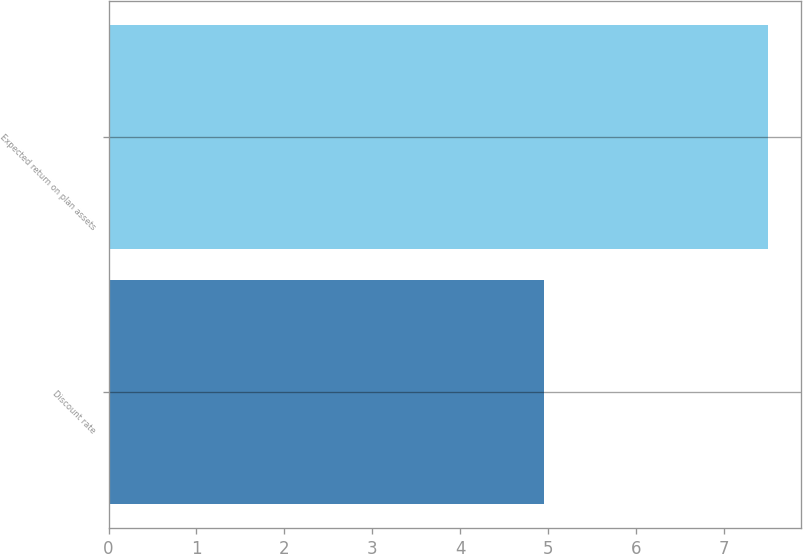<chart> <loc_0><loc_0><loc_500><loc_500><bar_chart><fcel>Discount rate<fcel>Expected return on plan assets<nl><fcel>4.95<fcel>7.5<nl></chart> 